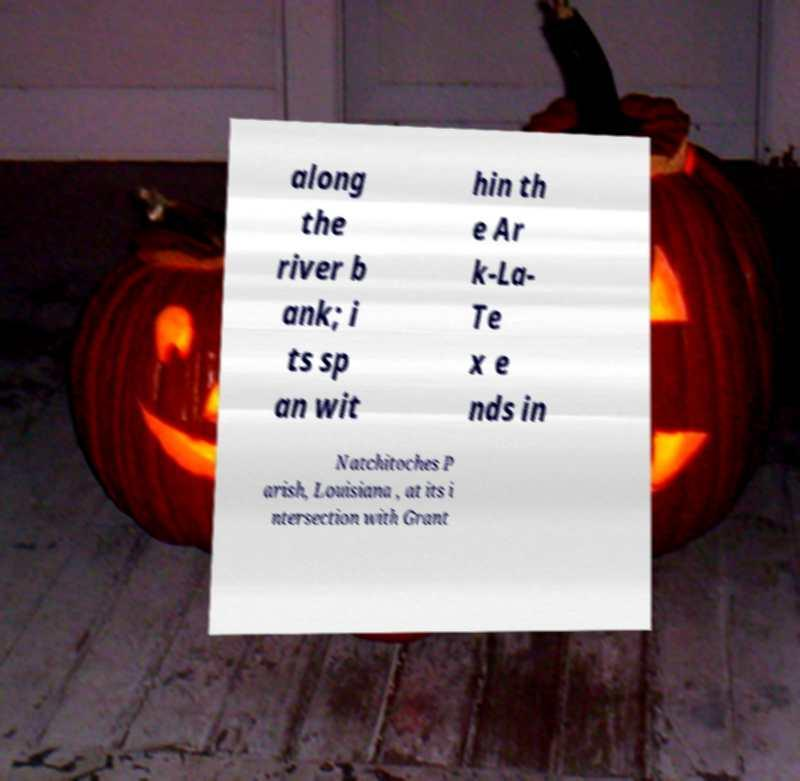For documentation purposes, I need the text within this image transcribed. Could you provide that? along the river b ank; i ts sp an wit hin th e Ar k-La- Te x e nds in Natchitoches P arish, Louisiana , at its i ntersection with Grant 